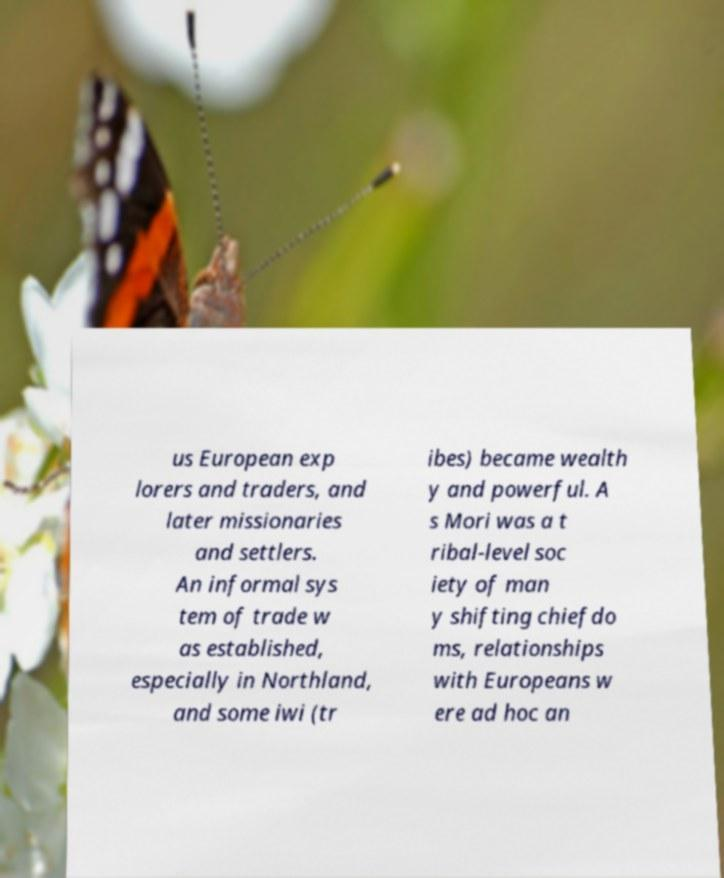What messages or text are displayed in this image? I need them in a readable, typed format. us European exp lorers and traders, and later missionaries and settlers. An informal sys tem of trade w as established, especially in Northland, and some iwi (tr ibes) became wealth y and powerful. A s Mori was a t ribal-level soc iety of man y shifting chiefdo ms, relationships with Europeans w ere ad hoc an 